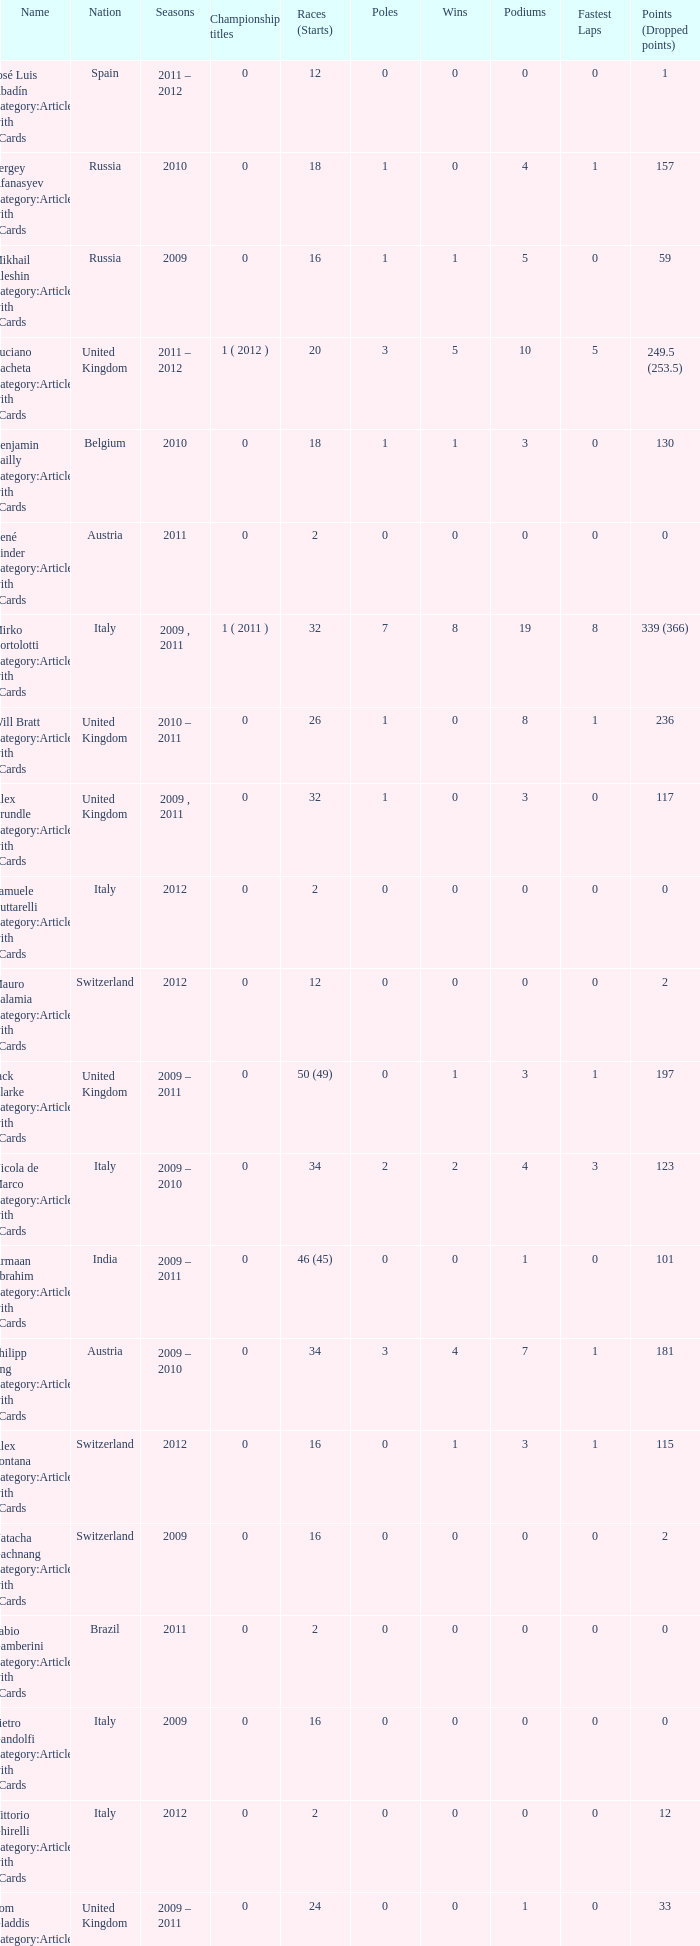What is the minimum amount of poles? 0.0. 